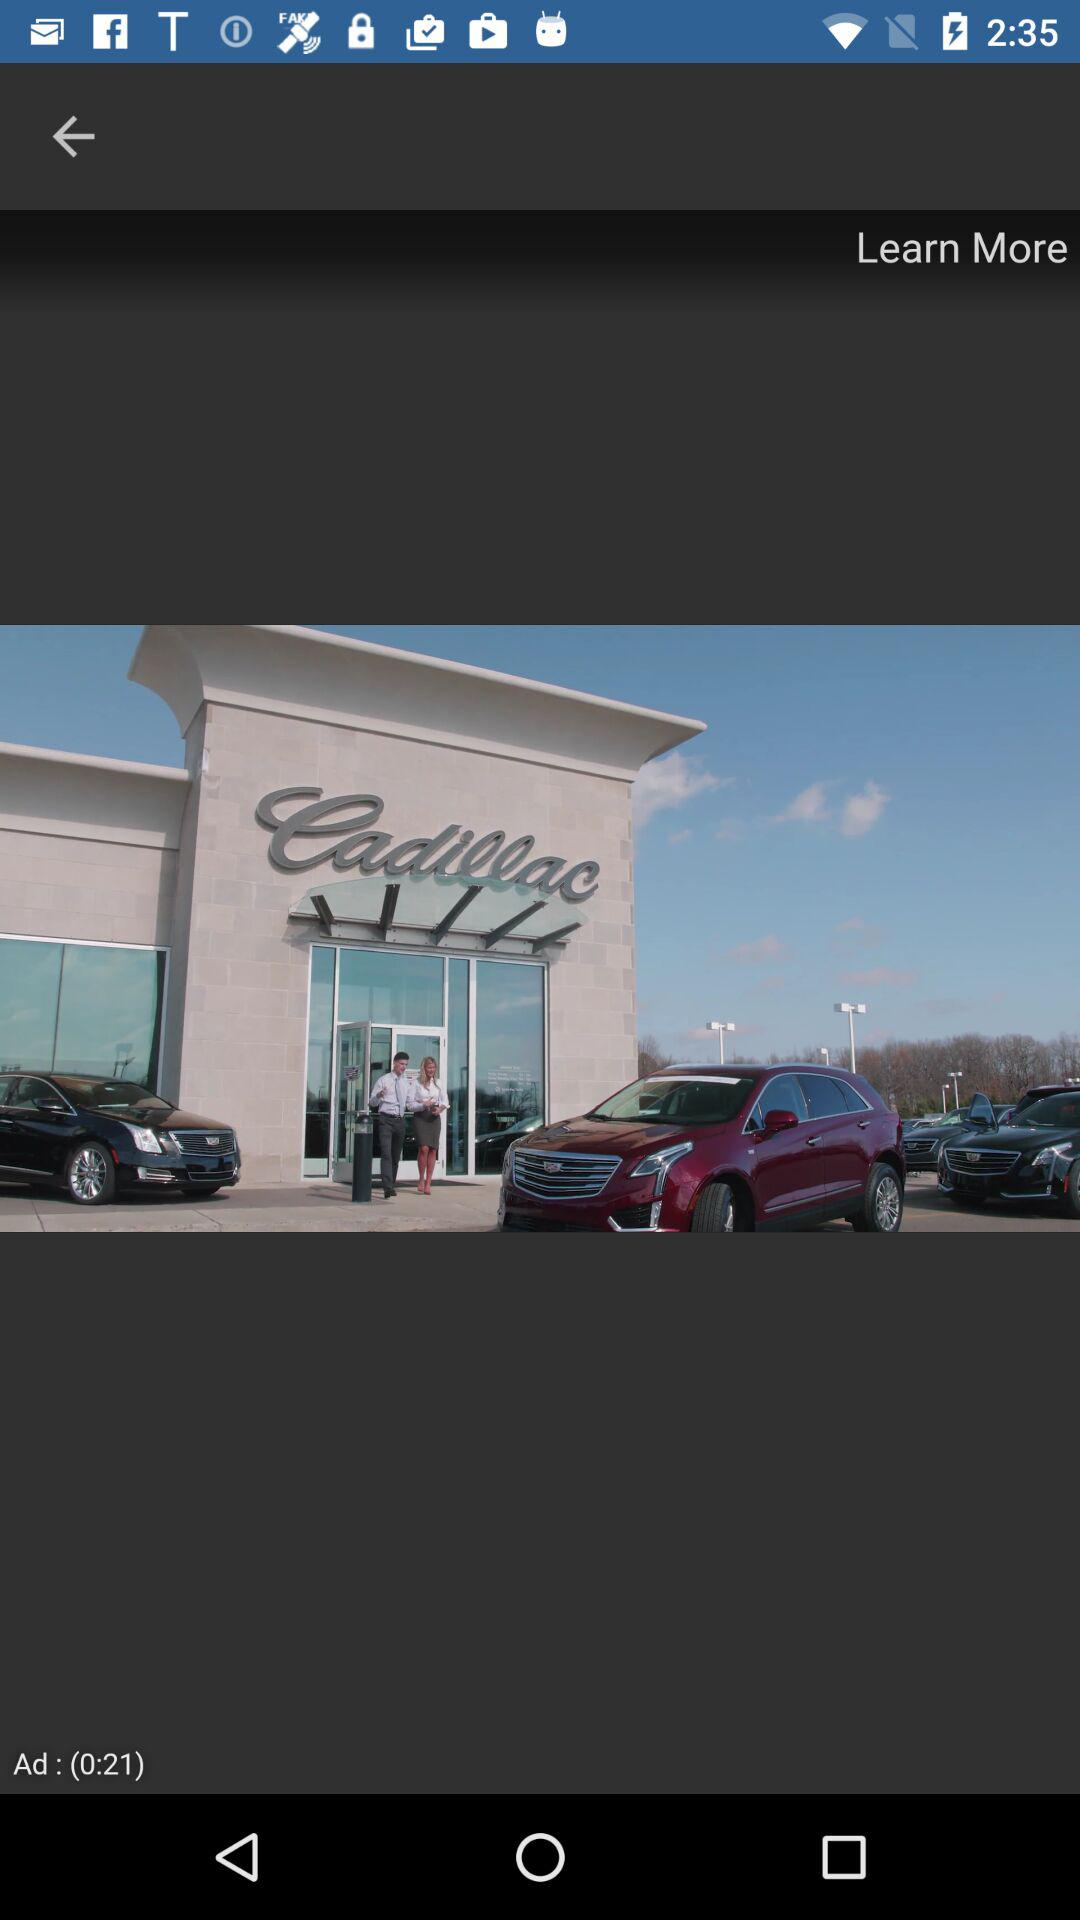What is the duration of the advertisement? The duration is 0:21. 